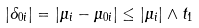Convert formula to latex. <formula><loc_0><loc_0><loc_500><loc_500>| \delta _ { 0 i } | = | \mu _ { i } - \mu _ { 0 i } | \leq | \mu _ { i } | \wedge t _ { 1 }</formula> 